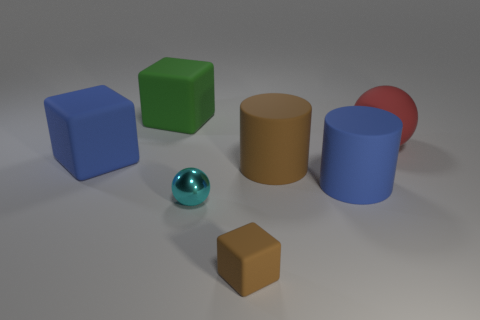Add 1 big red rubber spheres. How many objects exist? 8 Subtract all spheres. How many objects are left? 5 Add 2 small spheres. How many small spheres are left? 3 Add 2 blocks. How many blocks exist? 5 Subtract 0 blue spheres. How many objects are left? 7 Subtract all tiny cubes. Subtract all red rubber balls. How many objects are left? 5 